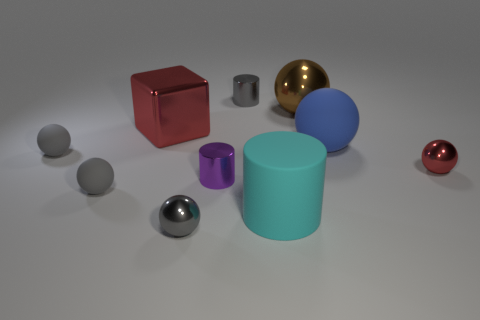Can you tell me about the lighting conditions in the scene? The lighting in the image appears soft and diffused, likely from an overhead source. It casts subtle shadows beneath each object, enhancing their three-dimensional appearance and providing a gentle illumination that does not create harsh reflections. How does the lighting affect the colors of the objects? Soft lighting allows the colors of the objects to remain vivid and distinct without becoming washed out. It helps in maintaining the integrity of colors like the deep red of the cube and the rich gold of the metallic sphere, making them stand out clearly against the lighter background. 